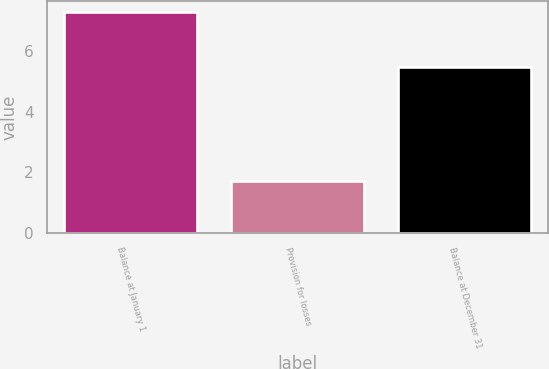<chart> <loc_0><loc_0><loc_500><loc_500><bar_chart><fcel>Balance at January 1<fcel>Provision for losses<fcel>Balance at December 31<nl><fcel>7.3<fcel>1.7<fcel>5.5<nl></chart> 